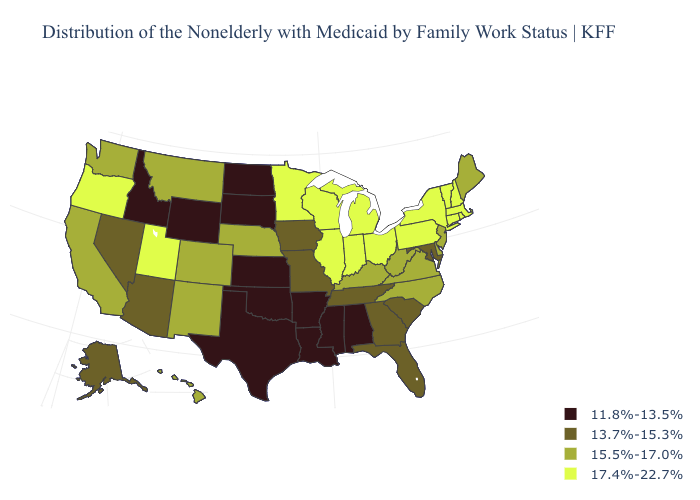Name the states that have a value in the range 11.8%-13.5%?
Give a very brief answer. Alabama, Arkansas, Idaho, Kansas, Louisiana, Mississippi, North Dakota, Oklahoma, South Dakota, Texas, Wyoming. Name the states that have a value in the range 17.4%-22.7%?
Keep it brief. Connecticut, Illinois, Indiana, Massachusetts, Michigan, Minnesota, New Hampshire, New York, Ohio, Oregon, Pennsylvania, Rhode Island, Utah, Vermont, Wisconsin. Name the states that have a value in the range 17.4%-22.7%?
Short answer required. Connecticut, Illinois, Indiana, Massachusetts, Michigan, Minnesota, New Hampshire, New York, Ohio, Oregon, Pennsylvania, Rhode Island, Utah, Vermont, Wisconsin. What is the value of Kansas?
Be succinct. 11.8%-13.5%. Name the states that have a value in the range 17.4%-22.7%?
Concise answer only. Connecticut, Illinois, Indiana, Massachusetts, Michigan, Minnesota, New Hampshire, New York, Ohio, Oregon, Pennsylvania, Rhode Island, Utah, Vermont, Wisconsin. Which states have the lowest value in the USA?
Keep it brief. Alabama, Arkansas, Idaho, Kansas, Louisiana, Mississippi, North Dakota, Oklahoma, South Dakota, Texas, Wyoming. Among the states that border California , does Arizona have the lowest value?
Write a very short answer. Yes. What is the lowest value in states that border Tennessee?
Answer briefly. 11.8%-13.5%. Name the states that have a value in the range 11.8%-13.5%?
Concise answer only. Alabama, Arkansas, Idaho, Kansas, Louisiana, Mississippi, North Dakota, Oklahoma, South Dakota, Texas, Wyoming. What is the value of Alaska?
Short answer required. 13.7%-15.3%. Which states have the lowest value in the USA?
Be succinct. Alabama, Arkansas, Idaho, Kansas, Louisiana, Mississippi, North Dakota, Oklahoma, South Dakota, Texas, Wyoming. Does Alaska have a higher value than Minnesota?
Answer briefly. No. What is the lowest value in the West?
Keep it brief. 11.8%-13.5%. What is the highest value in the USA?
Write a very short answer. 17.4%-22.7%. Among the states that border Massachusetts , which have the lowest value?
Be succinct. Connecticut, New Hampshire, New York, Rhode Island, Vermont. 